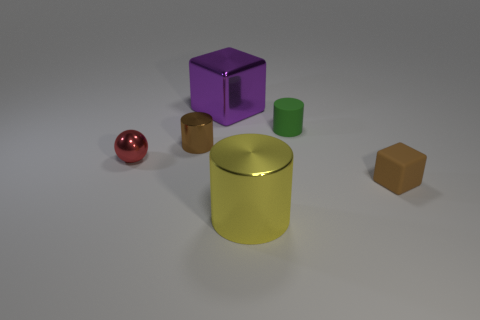The brown rubber thing has what size?
Make the answer very short. Small. The small brown shiny thing is what shape?
Your response must be concise. Cylinder. What number of things are both behind the small red metallic object and left of the yellow object?
Provide a succinct answer. 2. Does the tiny block have the same color as the big block?
Your response must be concise. No. There is a tiny green object that is the same shape as the yellow shiny object; what material is it?
Give a very brief answer. Rubber. Are there the same number of tiny things right of the rubber cylinder and tiny green objects that are in front of the small red ball?
Provide a short and direct response. No. Does the small brown cylinder have the same material as the small block?
Keep it short and to the point. No. How many cyan things are either tiny metallic cylinders or metallic objects?
Your answer should be very brief. 0. How many tiny green rubber things are the same shape as the red shiny thing?
Provide a succinct answer. 0. What material is the tiny block?
Offer a very short reply. Rubber. 